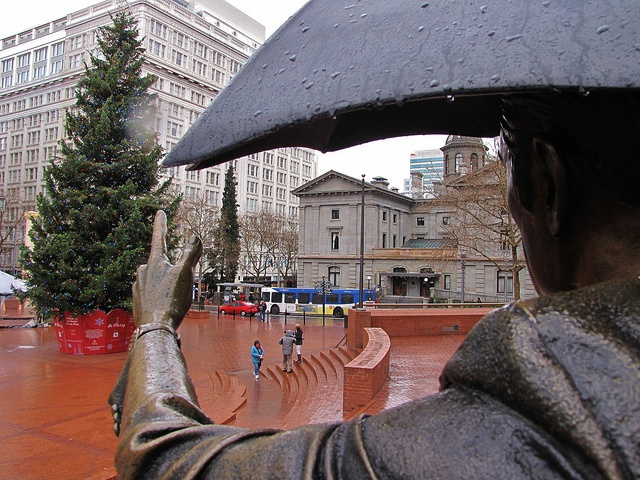Describe the objects in this image and their specific colors. I can see people in white, black, gray, and darkgray tones, umbrella in white, gray, and black tones, bus in white, black, blue, lightgray, and navy tones, car in white, brown, red, maroon, and black tones, and people in white, gray, black, and maroon tones in this image. 